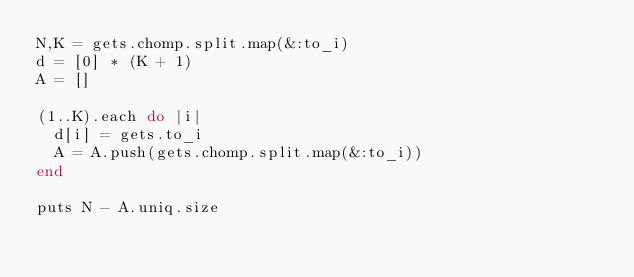<code> <loc_0><loc_0><loc_500><loc_500><_Ruby_>N,K = gets.chomp.split.map(&:to_i)
d = [0] * (K + 1)
A = []

(1..K).each do |i|
  d[i] = gets.to_i
  A = A.push(gets.chomp.split.map(&:to_i))
end

puts N - A.uniq.size</code> 